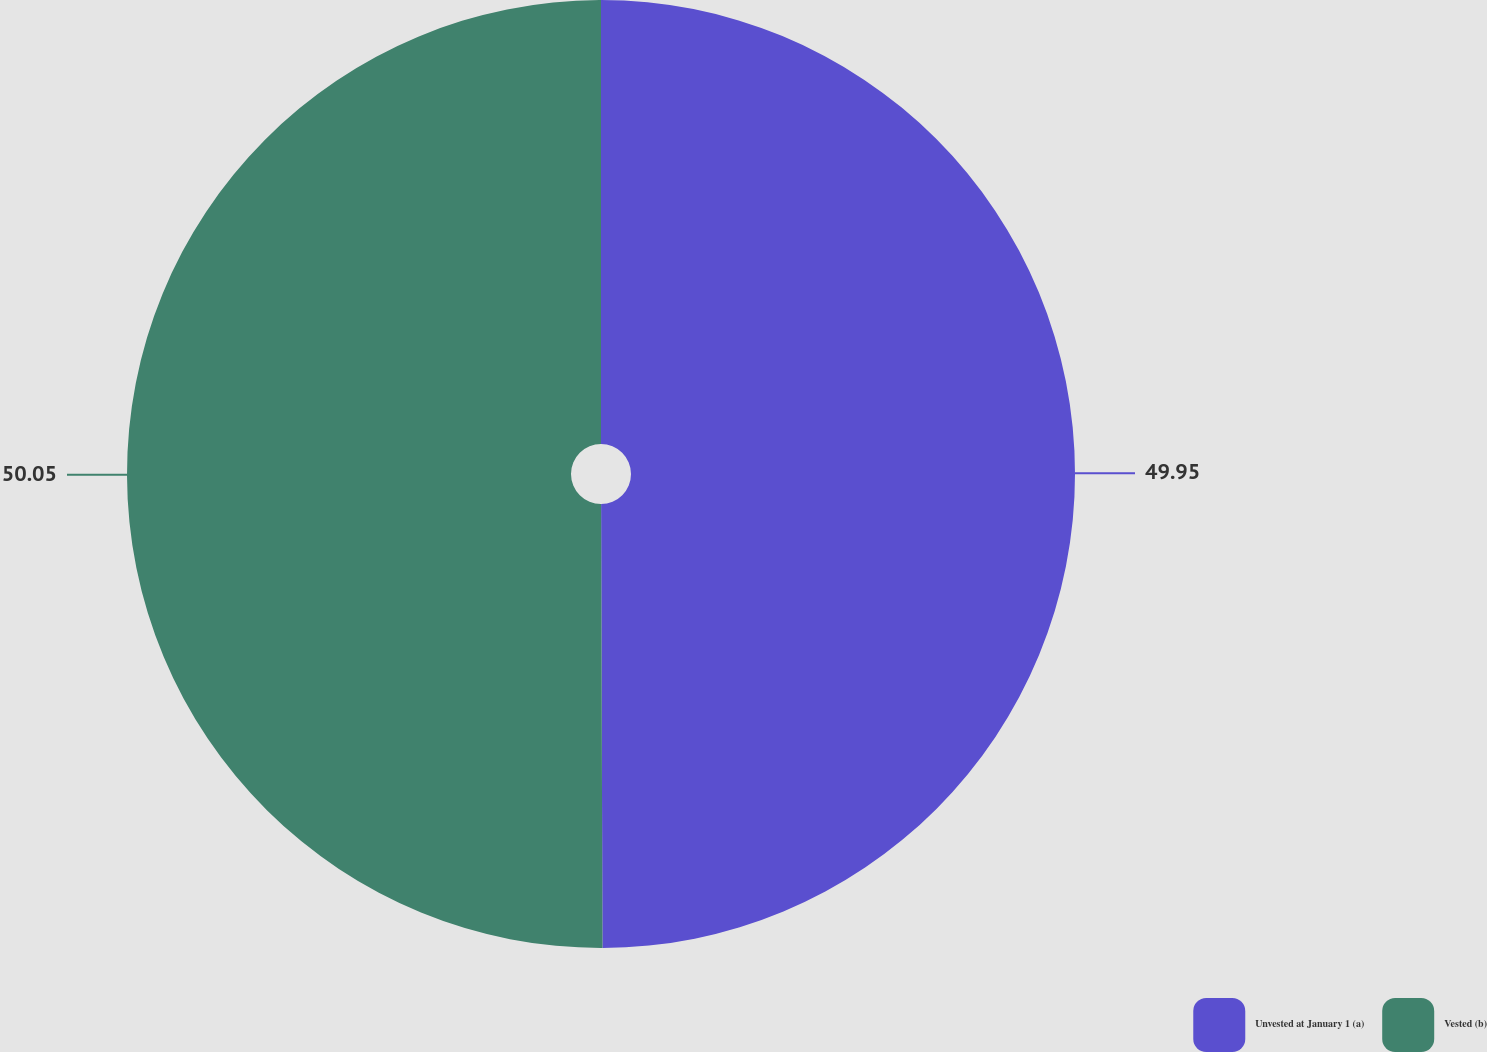<chart> <loc_0><loc_0><loc_500><loc_500><pie_chart><fcel>Unvested at January 1 (a)<fcel>Vested (b)<nl><fcel>49.95%<fcel>50.05%<nl></chart> 